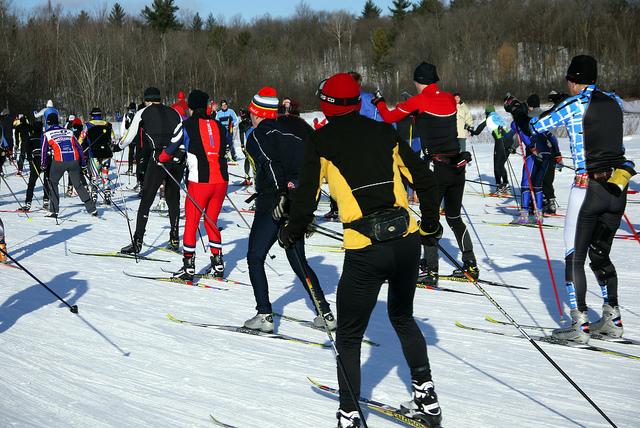What are these people doing?
Quick response, please. Skiing. Is the person closest wearing a fanny pack?
Concise answer only. Yes. Are all these people going in the same direction?
Be succinct. Yes. 